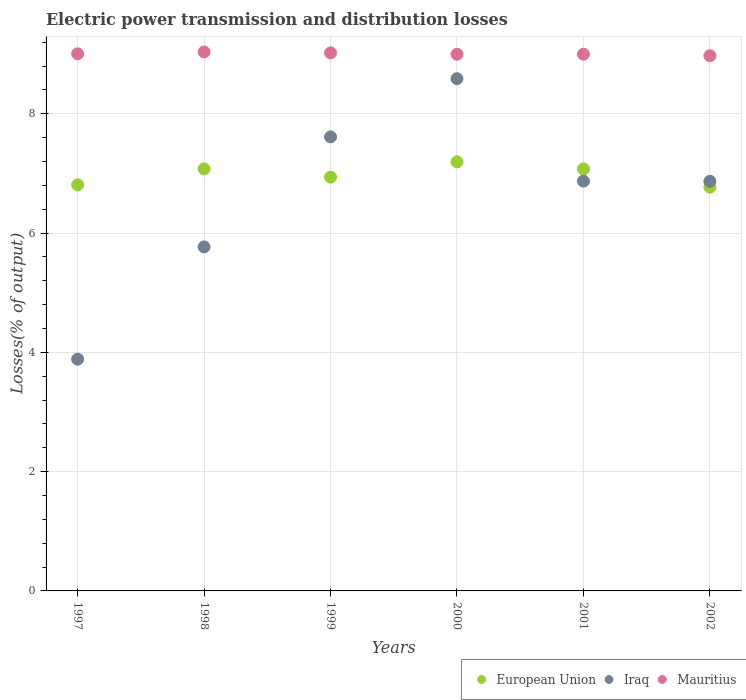How many different coloured dotlines are there?
Ensure brevity in your answer.  3. What is the electric power transmission and distribution losses in Iraq in 2000?
Offer a terse response. 8.59. Across all years, what is the maximum electric power transmission and distribution losses in European Union?
Offer a very short reply. 7.19. Across all years, what is the minimum electric power transmission and distribution losses in Mauritius?
Give a very brief answer. 8.97. In which year was the electric power transmission and distribution losses in Iraq maximum?
Provide a short and direct response. 2000. In which year was the electric power transmission and distribution losses in European Union minimum?
Provide a short and direct response. 2002. What is the total electric power transmission and distribution losses in Iraq in the graph?
Your answer should be very brief. 39.6. What is the difference between the electric power transmission and distribution losses in Iraq in 1998 and that in 2002?
Keep it short and to the point. -1.1. What is the difference between the electric power transmission and distribution losses in European Union in 2002 and the electric power transmission and distribution losses in Iraq in 2000?
Your answer should be compact. -1.82. What is the average electric power transmission and distribution losses in Iraq per year?
Make the answer very short. 6.6. In the year 2000, what is the difference between the electric power transmission and distribution losses in European Union and electric power transmission and distribution losses in Iraq?
Your answer should be very brief. -1.39. In how many years, is the electric power transmission and distribution losses in Mauritius greater than 4 %?
Provide a succinct answer. 6. What is the ratio of the electric power transmission and distribution losses in Mauritius in 1998 to that in 2002?
Offer a terse response. 1.01. Is the electric power transmission and distribution losses in European Union in 1997 less than that in 1998?
Your answer should be compact. Yes. What is the difference between the highest and the second highest electric power transmission and distribution losses in Mauritius?
Your response must be concise. 0.02. What is the difference between the highest and the lowest electric power transmission and distribution losses in European Union?
Your answer should be very brief. 0.42. In how many years, is the electric power transmission and distribution losses in Iraq greater than the average electric power transmission and distribution losses in Iraq taken over all years?
Offer a very short reply. 4. Is the sum of the electric power transmission and distribution losses in Iraq in 1998 and 1999 greater than the maximum electric power transmission and distribution losses in Mauritius across all years?
Your response must be concise. Yes. Is it the case that in every year, the sum of the electric power transmission and distribution losses in European Union and electric power transmission and distribution losses in Iraq  is greater than the electric power transmission and distribution losses in Mauritius?
Ensure brevity in your answer.  Yes. How many dotlines are there?
Provide a short and direct response. 3. Does the graph contain grids?
Your answer should be very brief. Yes. What is the title of the graph?
Make the answer very short. Electric power transmission and distribution losses. What is the label or title of the Y-axis?
Make the answer very short. Losses(% of output). What is the Losses(% of output) in European Union in 1997?
Make the answer very short. 6.81. What is the Losses(% of output) in Iraq in 1997?
Offer a terse response. 3.89. What is the Losses(% of output) of Mauritius in 1997?
Ensure brevity in your answer.  9.01. What is the Losses(% of output) of European Union in 1998?
Offer a terse response. 7.08. What is the Losses(% of output) of Iraq in 1998?
Offer a very short reply. 5.77. What is the Losses(% of output) of Mauritius in 1998?
Provide a short and direct response. 9.04. What is the Losses(% of output) in European Union in 1999?
Keep it short and to the point. 6.94. What is the Losses(% of output) in Iraq in 1999?
Offer a terse response. 7.61. What is the Losses(% of output) of Mauritius in 1999?
Provide a short and direct response. 9.02. What is the Losses(% of output) in European Union in 2000?
Your answer should be very brief. 7.19. What is the Losses(% of output) of Iraq in 2000?
Make the answer very short. 8.59. What is the Losses(% of output) of Mauritius in 2000?
Your answer should be compact. 9. What is the Losses(% of output) of European Union in 2001?
Offer a terse response. 7.08. What is the Losses(% of output) of Iraq in 2001?
Ensure brevity in your answer.  6.87. What is the Losses(% of output) of Mauritius in 2001?
Provide a succinct answer. 9. What is the Losses(% of output) of European Union in 2002?
Your response must be concise. 6.77. What is the Losses(% of output) in Iraq in 2002?
Make the answer very short. 6.87. What is the Losses(% of output) in Mauritius in 2002?
Give a very brief answer. 8.97. Across all years, what is the maximum Losses(% of output) in European Union?
Keep it short and to the point. 7.19. Across all years, what is the maximum Losses(% of output) of Iraq?
Your answer should be very brief. 8.59. Across all years, what is the maximum Losses(% of output) in Mauritius?
Your answer should be very brief. 9.04. Across all years, what is the minimum Losses(% of output) of European Union?
Ensure brevity in your answer.  6.77. Across all years, what is the minimum Losses(% of output) of Iraq?
Provide a short and direct response. 3.89. Across all years, what is the minimum Losses(% of output) in Mauritius?
Your answer should be very brief. 8.97. What is the total Losses(% of output) in European Union in the graph?
Give a very brief answer. 41.87. What is the total Losses(% of output) of Iraq in the graph?
Your answer should be very brief. 39.6. What is the total Losses(% of output) of Mauritius in the graph?
Provide a short and direct response. 54.04. What is the difference between the Losses(% of output) of European Union in 1997 and that in 1998?
Your response must be concise. -0.27. What is the difference between the Losses(% of output) in Iraq in 1997 and that in 1998?
Offer a very short reply. -1.88. What is the difference between the Losses(% of output) of Mauritius in 1997 and that in 1998?
Ensure brevity in your answer.  -0.03. What is the difference between the Losses(% of output) of European Union in 1997 and that in 1999?
Provide a succinct answer. -0.13. What is the difference between the Losses(% of output) in Iraq in 1997 and that in 1999?
Provide a short and direct response. -3.73. What is the difference between the Losses(% of output) in Mauritius in 1997 and that in 1999?
Offer a terse response. -0.02. What is the difference between the Losses(% of output) in European Union in 1997 and that in 2000?
Provide a succinct answer. -0.39. What is the difference between the Losses(% of output) of Iraq in 1997 and that in 2000?
Provide a succinct answer. -4.7. What is the difference between the Losses(% of output) in Mauritius in 1997 and that in 2000?
Your answer should be compact. 0.01. What is the difference between the Losses(% of output) of European Union in 1997 and that in 2001?
Your response must be concise. -0.27. What is the difference between the Losses(% of output) of Iraq in 1997 and that in 2001?
Provide a succinct answer. -2.98. What is the difference between the Losses(% of output) of Mauritius in 1997 and that in 2001?
Your answer should be very brief. 0.01. What is the difference between the Losses(% of output) in European Union in 1997 and that in 2002?
Offer a terse response. 0.04. What is the difference between the Losses(% of output) in Iraq in 1997 and that in 2002?
Provide a short and direct response. -2.98. What is the difference between the Losses(% of output) in Mauritius in 1997 and that in 2002?
Your answer should be very brief. 0.03. What is the difference between the Losses(% of output) in European Union in 1998 and that in 1999?
Ensure brevity in your answer.  0.14. What is the difference between the Losses(% of output) in Iraq in 1998 and that in 1999?
Offer a very short reply. -1.84. What is the difference between the Losses(% of output) of Mauritius in 1998 and that in 1999?
Your answer should be compact. 0.02. What is the difference between the Losses(% of output) of European Union in 1998 and that in 2000?
Your answer should be compact. -0.12. What is the difference between the Losses(% of output) in Iraq in 1998 and that in 2000?
Your response must be concise. -2.82. What is the difference between the Losses(% of output) of Mauritius in 1998 and that in 2000?
Make the answer very short. 0.04. What is the difference between the Losses(% of output) of European Union in 1998 and that in 2001?
Provide a short and direct response. 0. What is the difference between the Losses(% of output) in Iraq in 1998 and that in 2001?
Offer a very short reply. -1.1. What is the difference between the Losses(% of output) of Mauritius in 1998 and that in 2001?
Offer a terse response. 0.04. What is the difference between the Losses(% of output) in European Union in 1998 and that in 2002?
Offer a terse response. 0.31. What is the difference between the Losses(% of output) of Iraq in 1998 and that in 2002?
Ensure brevity in your answer.  -1.1. What is the difference between the Losses(% of output) of Mauritius in 1998 and that in 2002?
Your response must be concise. 0.06. What is the difference between the Losses(% of output) in European Union in 1999 and that in 2000?
Your answer should be compact. -0.26. What is the difference between the Losses(% of output) in Iraq in 1999 and that in 2000?
Make the answer very short. -0.98. What is the difference between the Losses(% of output) in Mauritius in 1999 and that in 2000?
Ensure brevity in your answer.  0.02. What is the difference between the Losses(% of output) of European Union in 1999 and that in 2001?
Provide a succinct answer. -0.14. What is the difference between the Losses(% of output) in Iraq in 1999 and that in 2001?
Your answer should be compact. 0.74. What is the difference between the Losses(% of output) of Mauritius in 1999 and that in 2001?
Make the answer very short. 0.02. What is the difference between the Losses(% of output) of European Union in 1999 and that in 2002?
Your answer should be very brief. 0.17. What is the difference between the Losses(% of output) in Iraq in 1999 and that in 2002?
Your answer should be compact. 0.74. What is the difference between the Losses(% of output) of Mauritius in 1999 and that in 2002?
Keep it short and to the point. 0.05. What is the difference between the Losses(% of output) in European Union in 2000 and that in 2001?
Your response must be concise. 0.12. What is the difference between the Losses(% of output) of Iraq in 2000 and that in 2001?
Offer a terse response. 1.72. What is the difference between the Losses(% of output) of Mauritius in 2000 and that in 2001?
Provide a short and direct response. -0. What is the difference between the Losses(% of output) in European Union in 2000 and that in 2002?
Give a very brief answer. 0.42. What is the difference between the Losses(% of output) in Iraq in 2000 and that in 2002?
Ensure brevity in your answer.  1.72. What is the difference between the Losses(% of output) of Mauritius in 2000 and that in 2002?
Offer a very short reply. 0.02. What is the difference between the Losses(% of output) of European Union in 2001 and that in 2002?
Your answer should be compact. 0.31. What is the difference between the Losses(% of output) in Iraq in 2001 and that in 2002?
Your answer should be very brief. 0. What is the difference between the Losses(% of output) in Mauritius in 2001 and that in 2002?
Provide a succinct answer. 0.03. What is the difference between the Losses(% of output) of European Union in 1997 and the Losses(% of output) of Iraq in 1998?
Offer a terse response. 1.04. What is the difference between the Losses(% of output) of European Union in 1997 and the Losses(% of output) of Mauritius in 1998?
Provide a succinct answer. -2.23. What is the difference between the Losses(% of output) of Iraq in 1997 and the Losses(% of output) of Mauritius in 1998?
Ensure brevity in your answer.  -5.15. What is the difference between the Losses(% of output) in European Union in 1997 and the Losses(% of output) in Iraq in 1999?
Your response must be concise. -0.8. What is the difference between the Losses(% of output) of European Union in 1997 and the Losses(% of output) of Mauritius in 1999?
Make the answer very short. -2.21. What is the difference between the Losses(% of output) in Iraq in 1997 and the Losses(% of output) in Mauritius in 1999?
Make the answer very short. -5.14. What is the difference between the Losses(% of output) of European Union in 1997 and the Losses(% of output) of Iraq in 2000?
Your response must be concise. -1.78. What is the difference between the Losses(% of output) of European Union in 1997 and the Losses(% of output) of Mauritius in 2000?
Offer a terse response. -2.19. What is the difference between the Losses(% of output) of Iraq in 1997 and the Losses(% of output) of Mauritius in 2000?
Give a very brief answer. -5.11. What is the difference between the Losses(% of output) of European Union in 1997 and the Losses(% of output) of Iraq in 2001?
Provide a succinct answer. -0.06. What is the difference between the Losses(% of output) of European Union in 1997 and the Losses(% of output) of Mauritius in 2001?
Give a very brief answer. -2.19. What is the difference between the Losses(% of output) in Iraq in 1997 and the Losses(% of output) in Mauritius in 2001?
Ensure brevity in your answer.  -5.11. What is the difference between the Losses(% of output) of European Union in 1997 and the Losses(% of output) of Iraq in 2002?
Provide a succinct answer. -0.06. What is the difference between the Losses(% of output) in European Union in 1997 and the Losses(% of output) in Mauritius in 2002?
Offer a terse response. -2.17. What is the difference between the Losses(% of output) of Iraq in 1997 and the Losses(% of output) of Mauritius in 2002?
Give a very brief answer. -5.09. What is the difference between the Losses(% of output) in European Union in 1998 and the Losses(% of output) in Iraq in 1999?
Your answer should be compact. -0.54. What is the difference between the Losses(% of output) of European Union in 1998 and the Losses(% of output) of Mauritius in 1999?
Give a very brief answer. -1.95. What is the difference between the Losses(% of output) of Iraq in 1998 and the Losses(% of output) of Mauritius in 1999?
Ensure brevity in your answer.  -3.25. What is the difference between the Losses(% of output) in European Union in 1998 and the Losses(% of output) in Iraq in 2000?
Offer a terse response. -1.51. What is the difference between the Losses(% of output) of European Union in 1998 and the Losses(% of output) of Mauritius in 2000?
Ensure brevity in your answer.  -1.92. What is the difference between the Losses(% of output) of Iraq in 1998 and the Losses(% of output) of Mauritius in 2000?
Keep it short and to the point. -3.23. What is the difference between the Losses(% of output) in European Union in 1998 and the Losses(% of output) in Iraq in 2001?
Offer a terse response. 0.21. What is the difference between the Losses(% of output) of European Union in 1998 and the Losses(% of output) of Mauritius in 2001?
Keep it short and to the point. -1.92. What is the difference between the Losses(% of output) in Iraq in 1998 and the Losses(% of output) in Mauritius in 2001?
Make the answer very short. -3.23. What is the difference between the Losses(% of output) in European Union in 1998 and the Losses(% of output) in Iraq in 2002?
Offer a very short reply. 0.21. What is the difference between the Losses(% of output) in European Union in 1998 and the Losses(% of output) in Mauritius in 2002?
Offer a terse response. -1.9. What is the difference between the Losses(% of output) in Iraq in 1998 and the Losses(% of output) in Mauritius in 2002?
Provide a succinct answer. -3.21. What is the difference between the Losses(% of output) of European Union in 1999 and the Losses(% of output) of Iraq in 2000?
Make the answer very short. -1.65. What is the difference between the Losses(% of output) of European Union in 1999 and the Losses(% of output) of Mauritius in 2000?
Offer a very short reply. -2.06. What is the difference between the Losses(% of output) in Iraq in 1999 and the Losses(% of output) in Mauritius in 2000?
Your response must be concise. -1.39. What is the difference between the Losses(% of output) in European Union in 1999 and the Losses(% of output) in Iraq in 2001?
Your answer should be very brief. 0.07. What is the difference between the Losses(% of output) in European Union in 1999 and the Losses(% of output) in Mauritius in 2001?
Your answer should be compact. -2.06. What is the difference between the Losses(% of output) in Iraq in 1999 and the Losses(% of output) in Mauritius in 2001?
Your answer should be compact. -1.39. What is the difference between the Losses(% of output) in European Union in 1999 and the Losses(% of output) in Iraq in 2002?
Give a very brief answer. 0.07. What is the difference between the Losses(% of output) in European Union in 1999 and the Losses(% of output) in Mauritius in 2002?
Your response must be concise. -2.04. What is the difference between the Losses(% of output) in Iraq in 1999 and the Losses(% of output) in Mauritius in 2002?
Give a very brief answer. -1.36. What is the difference between the Losses(% of output) in European Union in 2000 and the Losses(% of output) in Iraq in 2001?
Offer a terse response. 0.32. What is the difference between the Losses(% of output) of European Union in 2000 and the Losses(% of output) of Mauritius in 2001?
Your answer should be very brief. -1.81. What is the difference between the Losses(% of output) in Iraq in 2000 and the Losses(% of output) in Mauritius in 2001?
Provide a succinct answer. -0.41. What is the difference between the Losses(% of output) of European Union in 2000 and the Losses(% of output) of Iraq in 2002?
Provide a short and direct response. 0.33. What is the difference between the Losses(% of output) of European Union in 2000 and the Losses(% of output) of Mauritius in 2002?
Keep it short and to the point. -1.78. What is the difference between the Losses(% of output) in Iraq in 2000 and the Losses(% of output) in Mauritius in 2002?
Make the answer very short. -0.39. What is the difference between the Losses(% of output) in European Union in 2001 and the Losses(% of output) in Iraq in 2002?
Offer a terse response. 0.21. What is the difference between the Losses(% of output) of European Union in 2001 and the Losses(% of output) of Mauritius in 2002?
Make the answer very short. -1.9. What is the difference between the Losses(% of output) of Iraq in 2001 and the Losses(% of output) of Mauritius in 2002?
Offer a very short reply. -2.1. What is the average Losses(% of output) in European Union per year?
Provide a succinct answer. 6.98. What is the average Losses(% of output) in Iraq per year?
Your response must be concise. 6.6. What is the average Losses(% of output) in Mauritius per year?
Your response must be concise. 9.01. In the year 1997, what is the difference between the Losses(% of output) of European Union and Losses(% of output) of Iraq?
Your answer should be compact. 2.92. In the year 1997, what is the difference between the Losses(% of output) in European Union and Losses(% of output) in Mauritius?
Your answer should be compact. -2.2. In the year 1997, what is the difference between the Losses(% of output) of Iraq and Losses(% of output) of Mauritius?
Make the answer very short. -5.12. In the year 1998, what is the difference between the Losses(% of output) of European Union and Losses(% of output) of Iraq?
Give a very brief answer. 1.31. In the year 1998, what is the difference between the Losses(% of output) in European Union and Losses(% of output) in Mauritius?
Provide a short and direct response. -1.96. In the year 1998, what is the difference between the Losses(% of output) in Iraq and Losses(% of output) in Mauritius?
Your response must be concise. -3.27. In the year 1999, what is the difference between the Losses(% of output) of European Union and Losses(% of output) of Iraq?
Make the answer very short. -0.68. In the year 1999, what is the difference between the Losses(% of output) in European Union and Losses(% of output) in Mauritius?
Give a very brief answer. -2.08. In the year 1999, what is the difference between the Losses(% of output) of Iraq and Losses(% of output) of Mauritius?
Your answer should be compact. -1.41. In the year 2000, what is the difference between the Losses(% of output) of European Union and Losses(% of output) of Iraq?
Make the answer very short. -1.39. In the year 2000, what is the difference between the Losses(% of output) in European Union and Losses(% of output) in Mauritius?
Provide a short and direct response. -1.8. In the year 2000, what is the difference between the Losses(% of output) of Iraq and Losses(% of output) of Mauritius?
Give a very brief answer. -0.41. In the year 2001, what is the difference between the Losses(% of output) in European Union and Losses(% of output) in Iraq?
Offer a very short reply. 0.2. In the year 2001, what is the difference between the Losses(% of output) in European Union and Losses(% of output) in Mauritius?
Keep it short and to the point. -1.92. In the year 2001, what is the difference between the Losses(% of output) of Iraq and Losses(% of output) of Mauritius?
Ensure brevity in your answer.  -2.13. In the year 2002, what is the difference between the Losses(% of output) in European Union and Losses(% of output) in Iraq?
Your answer should be very brief. -0.1. In the year 2002, what is the difference between the Losses(% of output) in European Union and Losses(% of output) in Mauritius?
Your answer should be very brief. -2.2. In the year 2002, what is the difference between the Losses(% of output) in Iraq and Losses(% of output) in Mauritius?
Give a very brief answer. -2.11. What is the ratio of the Losses(% of output) of European Union in 1997 to that in 1998?
Offer a terse response. 0.96. What is the ratio of the Losses(% of output) in Iraq in 1997 to that in 1998?
Ensure brevity in your answer.  0.67. What is the ratio of the Losses(% of output) of Mauritius in 1997 to that in 1998?
Your response must be concise. 1. What is the ratio of the Losses(% of output) in European Union in 1997 to that in 1999?
Provide a succinct answer. 0.98. What is the ratio of the Losses(% of output) of Iraq in 1997 to that in 1999?
Ensure brevity in your answer.  0.51. What is the ratio of the Losses(% of output) of Mauritius in 1997 to that in 1999?
Keep it short and to the point. 1. What is the ratio of the Losses(% of output) in European Union in 1997 to that in 2000?
Keep it short and to the point. 0.95. What is the ratio of the Losses(% of output) in Iraq in 1997 to that in 2000?
Ensure brevity in your answer.  0.45. What is the ratio of the Losses(% of output) of Mauritius in 1997 to that in 2000?
Offer a terse response. 1. What is the ratio of the Losses(% of output) in European Union in 1997 to that in 2001?
Your answer should be compact. 0.96. What is the ratio of the Losses(% of output) of Iraq in 1997 to that in 2001?
Provide a short and direct response. 0.57. What is the ratio of the Losses(% of output) of Mauritius in 1997 to that in 2001?
Give a very brief answer. 1. What is the ratio of the Losses(% of output) in Iraq in 1997 to that in 2002?
Ensure brevity in your answer.  0.57. What is the ratio of the Losses(% of output) of Iraq in 1998 to that in 1999?
Your response must be concise. 0.76. What is the ratio of the Losses(% of output) of European Union in 1998 to that in 2000?
Provide a short and direct response. 0.98. What is the ratio of the Losses(% of output) of Iraq in 1998 to that in 2000?
Give a very brief answer. 0.67. What is the ratio of the Losses(% of output) of Mauritius in 1998 to that in 2000?
Your response must be concise. 1. What is the ratio of the Losses(% of output) in European Union in 1998 to that in 2001?
Make the answer very short. 1. What is the ratio of the Losses(% of output) of Iraq in 1998 to that in 2001?
Your answer should be very brief. 0.84. What is the ratio of the Losses(% of output) of Mauritius in 1998 to that in 2001?
Offer a terse response. 1. What is the ratio of the Losses(% of output) in European Union in 1998 to that in 2002?
Keep it short and to the point. 1.05. What is the ratio of the Losses(% of output) in Iraq in 1998 to that in 2002?
Provide a short and direct response. 0.84. What is the ratio of the Losses(% of output) in Mauritius in 1998 to that in 2002?
Give a very brief answer. 1.01. What is the ratio of the Losses(% of output) of Iraq in 1999 to that in 2000?
Your answer should be very brief. 0.89. What is the ratio of the Losses(% of output) of Mauritius in 1999 to that in 2000?
Your answer should be compact. 1. What is the ratio of the Losses(% of output) of European Union in 1999 to that in 2001?
Your response must be concise. 0.98. What is the ratio of the Losses(% of output) of Iraq in 1999 to that in 2001?
Ensure brevity in your answer.  1.11. What is the ratio of the Losses(% of output) of European Union in 1999 to that in 2002?
Ensure brevity in your answer.  1.02. What is the ratio of the Losses(% of output) in Iraq in 1999 to that in 2002?
Your answer should be compact. 1.11. What is the ratio of the Losses(% of output) in European Union in 2000 to that in 2001?
Ensure brevity in your answer.  1.02. What is the ratio of the Losses(% of output) of Iraq in 2000 to that in 2001?
Ensure brevity in your answer.  1.25. What is the ratio of the Losses(% of output) in Mauritius in 2000 to that in 2001?
Give a very brief answer. 1. What is the ratio of the Losses(% of output) in European Union in 2000 to that in 2002?
Give a very brief answer. 1.06. What is the ratio of the Losses(% of output) in Iraq in 2000 to that in 2002?
Offer a very short reply. 1.25. What is the ratio of the Losses(% of output) of European Union in 2001 to that in 2002?
Make the answer very short. 1.05. What is the ratio of the Losses(% of output) of Iraq in 2001 to that in 2002?
Offer a terse response. 1. What is the ratio of the Losses(% of output) in Mauritius in 2001 to that in 2002?
Make the answer very short. 1. What is the difference between the highest and the second highest Losses(% of output) of European Union?
Keep it short and to the point. 0.12. What is the difference between the highest and the second highest Losses(% of output) in Mauritius?
Your answer should be very brief. 0.02. What is the difference between the highest and the lowest Losses(% of output) of European Union?
Give a very brief answer. 0.42. What is the difference between the highest and the lowest Losses(% of output) of Iraq?
Provide a short and direct response. 4.7. What is the difference between the highest and the lowest Losses(% of output) of Mauritius?
Your answer should be very brief. 0.06. 